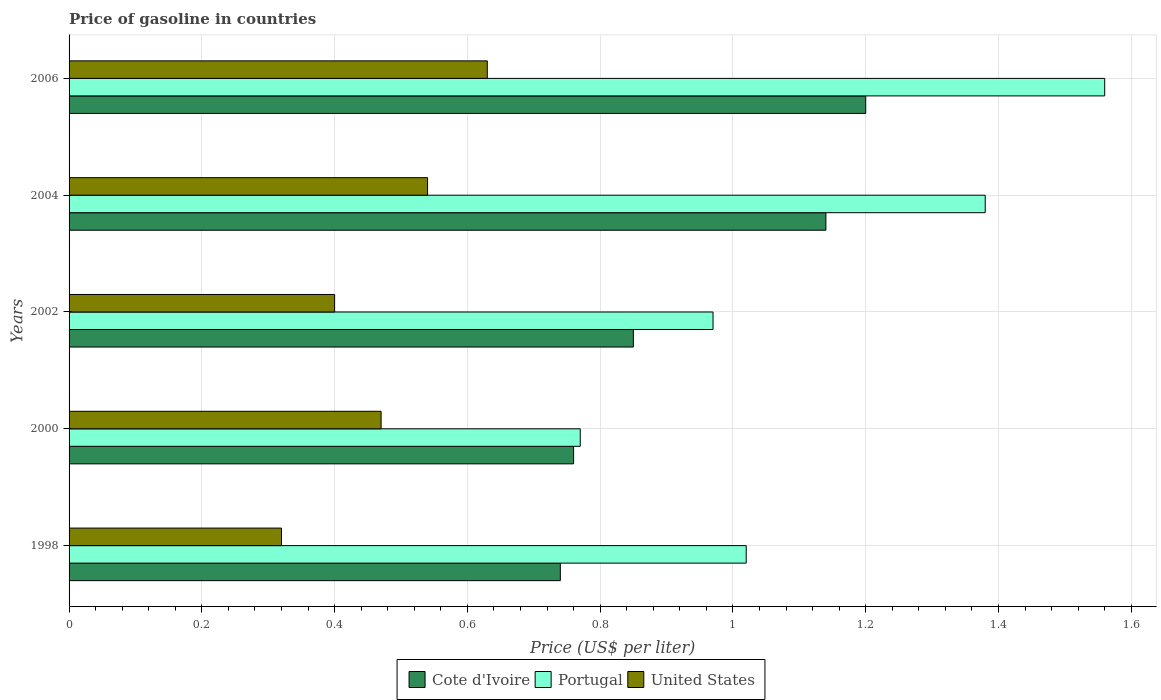How many different coloured bars are there?
Give a very brief answer. 3. How many groups of bars are there?
Provide a short and direct response. 5. Are the number of bars per tick equal to the number of legend labels?
Make the answer very short. Yes. How many bars are there on the 5th tick from the top?
Give a very brief answer. 3. How many bars are there on the 5th tick from the bottom?
Ensure brevity in your answer.  3. What is the price of gasoline in Portugal in 2000?
Keep it short and to the point. 0.77. Across all years, what is the maximum price of gasoline in Cote d'Ivoire?
Your answer should be very brief. 1.2. Across all years, what is the minimum price of gasoline in Portugal?
Give a very brief answer. 0.77. In which year was the price of gasoline in Cote d'Ivoire minimum?
Provide a short and direct response. 1998. What is the total price of gasoline in Portugal in the graph?
Provide a short and direct response. 5.7. What is the difference between the price of gasoline in United States in 2000 and that in 2006?
Your response must be concise. -0.16. What is the difference between the price of gasoline in Portugal in 2004 and the price of gasoline in United States in 2000?
Give a very brief answer. 0.91. What is the average price of gasoline in United States per year?
Offer a very short reply. 0.47. In the year 2000, what is the difference between the price of gasoline in United States and price of gasoline in Portugal?
Make the answer very short. -0.3. In how many years, is the price of gasoline in Portugal greater than 1.4800000000000002 US$?
Offer a terse response. 1. What is the ratio of the price of gasoline in Portugal in 1998 to that in 2002?
Provide a succinct answer. 1.05. What is the difference between the highest and the second highest price of gasoline in Portugal?
Your answer should be very brief. 0.18. What is the difference between the highest and the lowest price of gasoline in Cote d'Ivoire?
Offer a terse response. 0.46. In how many years, is the price of gasoline in Cote d'Ivoire greater than the average price of gasoline in Cote d'Ivoire taken over all years?
Offer a very short reply. 2. What does the 3rd bar from the top in 2000 represents?
Keep it short and to the point. Cote d'Ivoire. What does the 1st bar from the bottom in 2004 represents?
Keep it short and to the point. Cote d'Ivoire. Is it the case that in every year, the sum of the price of gasoline in United States and price of gasoline in Portugal is greater than the price of gasoline in Cote d'Ivoire?
Offer a terse response. Yes. What is the difference between two consecutive major ticks on the X-axis?
Offer a very short reply. 0.2. Are the values on the major ticks of X-axis written in scientific E-notation?
Your answer should be compact. No. Where does the legend appear in the graph?
Provide a short and direct response. Bottom center. What is the title of the graph?
Offer a terse response. Price of gasoline in countries. Does "Middle income" appear as one of the legend labels in the graph?
Your answer should be compact. No. What is the label or title of the X-axis?
Provide a succinct answer. Price (US$ per liter). What is the label or title of the Y-axis?
Provide a short and direct response. Years. What is the Price (US$ per liter) in Cote d'Ivoire in 1998?
Provide a short and direct response. 0.74. What is the Price (US$ per liter) in United States in 1998?
Ensure brevity in your answer.  0.32. What is the Price (US$ per liter) of Cote d'Ivoire in 2000?
Your response must be concise. 0.76. What is the Price (US$ per liter) of Portugal in 2000?
Ensure brevity in your answer.  0.77. What is the Price (US$ per liter) of United States in 2000?
Make the answer very short. 0.47. What is the Price (US$ per liter) in Cote d'Ivoire in 2004?
Make the answer very short. 1.14. What is the Price (US$ per liter) of Portugal in 2004?
Your answer should be very brief. 1.38. What is the Price (US$ per liter) of United States in 2004?
Make the answer very short. 0.54. What is the Price (US$ per liter) in Cote d'Ivoire in 2006?
Keep it short and to the point. 1.2. What is the Price (US$ per liter) in Portugal in 2006?
Your answer should be very brief. 1.56. What is the Price (US$ per liter) of United States in 2006?
Your answer should be very brief. 0.63. Across all years, what is the maximum Price (US$ per liter) of Cote d'Ivoire?
Give a very brief answer. 1.2. Across all years, what is the maximum Price (US$ per liter) of Portugal?
Offer a very short reply. 1.56. Across all years, what is the maximum Price (US$ per liter) in United States?
Make the answer very short. 0.63. Across all years, what is the minimum Price (US$ per liter) in Cote d'Ivoire?
Make the answer very short. 0.74. Across all years, what is the minimum Price (US$ per liter) in Portugal?
Provide a succinct answer. 0.77. Across all years, what is the minimum Price (US$ per liter) of United States?
Your answer should be very brief. 0.32. What is the total Price (US$ per liter) of Cote d'Ivoire in the graph?
Your response must be concise. 4.69. What is the total Price (US$ per liter) in United States in the graph?
Your response must be concise. 2.36. What is the difference between the Price (US$ per liter) of Cote d'Ivoire in 1998 and that in 2000?
Your answer should be compact. -0.02. What is the difference between the Price (US$ per liter) of Portugal in 1998 and that in 2000?
Provide a succinct answer. 0.25. What is the difference between the Price (US$ per liter) of Cote d'Ivoire in 1998 and that in 2002?
Offer a terse response. -0.11. What is the difference between the Price (US$ per liter) in Portugal in 1998 and that in 2002?
Make the answer very short. 0.05. What is the difference between the Price (US$ per liter) of United States in 1998 and that in 2002?
Give a very brief answer. -0.08. What is the difference between the Price (US$ per liter) in Cote d'Ivoire in 1998 and that in 2004?
Your answer should be very brief. -0.4. What is the difference between the Price (US$ per liter) of Portugal in 1998 and that in 2004?
Make the answer very short. -0.36. What is the difference between the Price (US$ per liter) in United States in 1998 and that in 2004?
Keep it short and to the point. -0.22. What is the difference between the Price (US$ per liter) of Cote d'Ivoire in 1998 and that in 2006?
Offer a terse response. -0.46. What is the difference between the Price (US$ per liter) of Portugal in 1998 and that in 2006?
Your answer should be compact. -0.54. What is the difference between the Price (US$ per liter) of United States in 1998 and that in 2006?
Make the answer very short. -0.31. What is the difference between the Price (US$ per liter) in Cote d'Ivoire in 2000 and that in 2002?
Offer a terse response. -0.09. What is the difference between the Price (US$ per liter) in United States in 2000 and that in 2002?
Give a very brief answer. 0.07. What is the difference between the Price (US$ per liter) of Cote d'Ivoire in 2000 and that in 2004?
Provide a succinct answer. -0.38. What is the difference between the Price (US$ per liter) of Portugal in 2000 and that in 2004?
Make the answer very short. -0.61. What is the difference between the Price (US$ per liter) of United States in 2000 and that in 2004?
Keep it short and to the point. -0.07. What is the difference between the Price (US$ per liter) in Cote d'Ivoire in 2000 and that in 2006?
Your response must be concise. -0.44. What is the difference between the Price (US$ per liter) of Portugal in 2000 and that in 2006?
Make the answer very short. -0.79. What is the difference between the Price (US$ per liter) in United States in 2000 and that in 2006?
Offer a terse response. -0.16. What is the difference between the Price (US$ per liter) in Cote d'Ivoire in 2002 and that in 2004?
Ensure brevity in your answer.  -0.29. What is the difference between the Price (US$ per liter) of Portugal in 2002 and that in 2004?
Ensure brevity in your answer.  -0.41. What is the difference between the Price (US$ per liter) of United States in 2002 and that in 2004?
Offer a terse response. -0.14. What is the difference between the Price (US$ per liter) of Cote d'Ivoire in 2002 and that in 2006?
Provide a succinct answer. -0.35. What is the difference between the Price (US$ per liter) in Portugal in 2002 and that in 2006?
Ensure brevity in your answer.  -0.59. What is the difference between the Price (US$ per liter) of United States in 2002 and that in 2006?
Provide a short and direct response. -0.23. What is the difference between the Price (US$ per liter) of Cote d'Ivoire in 2004 and that in 2006?
Offer a terse response. -0.06. What is the difference between the Price (US$ per liter) in Portugal in 2004 and that in 2006?
Your answer should be very brief. -0.18. What is the difference between the Price (US$ per liter) in United States in 2004 and that in 2006?
Ensure brevity in your answer.  -0.09. What is the difference between the Price (US$ per liter) in Cote d'Ivoire in 1998 and the Price (US$ per liter) in Portugal in 2000?
Offer a terse response. -0.03. What is the difference between the Price (US$ per liter) in Cote d'Ivoire in 1998 and the Price (US$ per liter) in United States in 2000?
Make the answer very short. 0.27. What is the difference between the Price (US$ per liter) of Portugal in 1998 and the Price (US$ per liter) of United States in 2000?
Give a very brief answer. 0.55. What is the difference between the Price (US$ per liter) of Cote d'Ivoire in 1998 and the Price (US$ per liter) of Portugal in 2002?
Your response must be concise. -0.23. What is the difference between the Price (US$ per liter) in Cote d'Ivoire in 1998 and the Price (US$ per liter) in United States in 2002?
Give a very brief answer. 0.34. What is the difference between the Price (US$ per liter) in Portugal in 1998 and the Price (US$ per liter) in United States in 2002?
Ensure brevity in your answer.  0.62. What is the difference between the Price (US$ per liter) in Cote d'Ivoire in 1998 and the Price (US$ per liter) in Portugal in 2004?
Your answer should be very brief. -0.64. What is the difference between the Price (US$ per liter) in Cote d'Ivoire in 1998 and the Price (US$ per liter) in United States in 2004?
Ensure brevity in your answer.  0.2. What is the difference between the Price (US$ per liter) in Portugal in 1998 and the Price (US$ per liter) in United States in 2004?
Offer a very short reply. 0.48. What is the difference between the Price (US$ per liter) of Cote d'Ivoire in 1998 and the Price (US$ per liter) of Portugal in 2006?
Your answer should be compact. -0.82. What is the difference between the Price (US$ per liter) of Cote d'Ivoire in 1998 and the Price (US$ per liter) of United States in 2006?
Offer a very short reply. 0.11. What is the difference between the Price (US$ per liter) in Portugal in 1998 and the Price (US$ per liter) in United States in 2006?
Provide a short and direct response. 0.39. What is the difference between the Price (US$ per liter) of Cote d'Ivoire in 2000 and the Price (US$ per liter) of Portugal in 2002?
Your answer should be compact. -0.21. What is the difference between the Price (US$ per liter) of Cote d'Ivoire in 2000 and the Price (US$ per liter) of United States in 2002?
Provide a succinct answer. 0.36. What is the difference between the Price (US$ per liter) in Portugal in 2000 and the Price (US$ per liter) in United States in 2002?
Offer a very short reply. 0.37. What is the difference between the Price (US$ per liter) in Cote d'Ivoire in 2000 and the Price (US$ per liter) in Portugal in 2004?
Provide a short and direct response. -0.62. What is the difference between the Price (US$ per liter) of Cote d'Ivoire in 2000 and the Price (US$ per liter) of United States in 2004?
Your answer should be compact. 0.22. What is the difference between the Price (US$ per liter) of Portugal in 2000 and the Price (US$ per liter) of United States in 2004?
Provide a short and direct response. 0.23. What is the difference between the Price (US$ per liter) in Cote d'Ivoire in 2000 and the Price (US$ per liter) in United States in 2006?
Offer a terse response. 0.13. What is the difference between the Price (US$ per liter) of Portugal in 2000 and the Price (US$ per liter) of United States in 2006?
Ensure brevity in your answer.  0.14. What is the difference between the Price (US$ per liter) of Cote d'Ivoire in 2002 and the Price (US$ per liter) of Portugal in 2004?
Give a very brief answer. -0.53. What is the difference between the Price (US$ per liter) of Cote d'Ivoire in 2002 and the Price (US$ per liter) of United States in 2004?
Provide a short and direct response. 0.31. What is the difference between the Price (US$ per liter) of Portugal in 2002 and the Price (US$ per liter) of United States in 2004?
Give a very brief answer. 0.43. What is the difference between the Price (US$ per liter) in Cote d'Ivoire in 2002 and the Price (US$ per liter) in Portugal in 2006?
Provide a succinct answer. -0.71. What is the difference between the Price (US$ per liter) in Cote d'Ivoire in 2002 and the Price (US$ per liter) in United States in 2006?
Keep it short and to the point. 0.22. What is the difference between the Price (US$ per liter) in Portugal in 2002 and the Price (US$ per liter) in United States in 2006?
Ensure brevity in your answer.  0.34. What is the difference between the Price (US$ per liter) of Cote d'Ivoire in 2004 and the Price (US$ per liter) of Portugal in 2006?
Provide a succinct answer. -0.42. What is the difference between the Price (US$ per liter) of Cote d'Ivoire in 2004 and the Price (US$ per liter) of United States in 2006?
Your answer should be very brief. 0.51. What is the difference between the Price (US$ per liter) in Portugal in 2004 and the Price (US$ per liter) in United States in 2006?
Make the answer very short. 0.75. What is the average Price (US$ per liter) of Cote d'Ivoire per year?
Give a very brief answer. 0.94. What is the average Price (US$ per liter) in Portugal per year?
Provide a short and direct response. 1.14. What is the average Price (US$ per liter) of United States per year?
Your answer should be compact. 0.47. In the year 1998, what is the difference between the Price (US$ per liter) in Cote d'Ivoire and Price (US$ per liter) in Portugal?
Offer a very short reply. -0.28. In the year 1998, what is the difference between the Price (US$ per liter) in Cote d'Ivoire and Price (US$ per liter) in United States?
Your answer should be very brief. 0.42. In the year 2000, what is the difference between the Price (US$ per liter) of Cote d'Ivoire and Price (US$ per liter) of Portugal?
Your response must be concise. -0.01. In the year 2000, what is the difference between the Price (US$ per liter) in Cote d'Ivoire and Price (US$ per liter) in United States?
Your response must be concise. 0.29. In the year 2002, what is the difference between the Price (US$ per liter) in Cote d'Ivoire and Price (US$ per liter) in Portugal?
Provide a short and direct response. -0.12. In the year 2002, what is the difference between the Price (US$ per liter) of Cote d'Ivoire and Price (US$ per liter) of United States?
Provide a short and direct response. 0.45. In the year 2002, what is the difference between the Price (US$ per liter) of Portugal and Price (US$ per liter) of United States?
Make the answer very short. 0.57. In the year 2004, what is the difference between the Price (US$ per liter) of Cote d'Ivoire and Price (US$ per liter) of Portugal?
Your answer should be very brief. -0.24. In the year 2004, what is the difference between the Price (US$ per liter) of Portugal and Price (US$ per liter) of United States?
Provide a short and direct response. 0.84. In the year 2006, what is the difference between the Price (US$ per liter) in Cote d'Ivoire and Price (US$ per liter) in Portugal?
Your response must be concise. -0.36. In the year 2006, what is the difference between the Price (US$ per liter) in Cote d'Ivoire and Price (US$ per liter) in United States?
Provide a succinct answer. 0.57. What is the ratio of the Price (US$ per liter) of Cote d'Ivoire in 1998 to that in 2000?
Your answer should be compact. 0.97. What is the ratio of the Price (US$ per liter) in Portugal in 1998 to that in 2000?
Your answer should be very brief. 1.32. What is the ratio of the Price (US$ per liter) of United States in 1998 to that in 2000?
Your answer should be very brief. 0.68. What is the ratio of the Price (US$ per liter) of Cote d'Ivoire in 1998 to that in 2002?
Your response must be concise. 0.87. What is the ratio of the Price (US$ per liter) of Portugal in 1998 to that in 2002?
Your answer should be compact. 1.05. What is the ratio of the Price (US$ per liter) of United States in 1998 to that in 2002?
Ensure brevity in your answer.  0.8. What is the ratio of the Price (US$ per liter) in Cote d'Ivoire in 1998 to that in 2004?
Ensure brevity in your answer.  0.65. What is the ratio of the Price (US$ per liter) in Portugal in 1998 to that in 2004?
Ensure brevity in your answer.  0.74. What is the ratio of the Price (US$ per liter) in United States in 1998 to that in 2004?
Give a very brief answer. 0.59. What is the ratio of the Price (US$ per liter) of Cote d'Ivoire in 1998 to that in 2006?
Your answer should be compact. 0.62. What is the ratio of the Price (US$ per liter) of Portugal in 1998 to that in 2006?
Give a very brief answer. 0.65. What is the ratio of the Price (US$ per liter) in United States in 1998 to that in 2006?
Provide a succinct answer. 0.51. What is the ratio of the Price (US$ per liter) in Cote d'Ivoire in 2000 to that in 2002?
Your answer should be very brief. 0.89. What is the ratio of the Price (US$ per liter) in Portugal in 2000 to that in 2002?
Keep it short and to the point. 0.79. What is the ratio of the Price (US$ per liter) in United States in 2000 to that in 2002?
Give a very brief answer. 1.18. What is the ratio of the Price (US$ per liter) of Portugal in 2000 to that in 2004?
Your response must be concise. 0.56. What is the ratio of the Price (US$ per liter) in United States in 2000 to that in 2004?
Your answer should be compact. 0.87. What is the ratio of the Price (US$ per liter) of Cote d'Ivoire in 2000 to that in 2006?
Make the answer very short. 0.63. What is the ratio of the Price (US$ per liter) of Portugal in 2000 to that in 2006?
Your response must be concise. 0.49. What is the ratio of the Price (US$ per liter) of United States in 2000 to that in 2006?
Provide a succinct answer. 0.75. What is the ratio of the Price (US$ per liter) of Cote d'Ivoire in 2002 to that in 2004?
Provide a succinct answer. 0.75. What is the ratio of the Price (US$ per liter) of Portugal in 2002 to that in 2004?
Offer a very short reply. 0.7. What is the ratio of the Price (US$ per liter) of United States in 2002 to that in 2004?
Offer a very short reply. 0.74. What is the ratio of the Price (US$ per liter) of Cote d'Ivoire in 2002 to that in 2006?
Your answer should be compact. 0.71. What is the ratio of the Price (US$ per liter) in Portugal in 2002 to that in 2006?
Provide a succinct answer. 0.62. What is the ratio of the Price (US$ per liter) in United States in 2002 to that in 2006?
Ensure brevity in your answer.  0.63. What is the ratio of the Price (US$ per liter) in Portugal in 2004 to that in 2006?
Your answer should be compact. 0.88. What is the ratio of the Price (US$ per liter) in United States in 2004 to that in 2006?
Make the answer very short. 0.86. What is the difference between the highest and the second highest Price (US$ per liter) of Cote d'Ivoire?
Your answer should be compact. 0.06. What is the difference between the highest and the second highest Price (US$ per liter) in Portugal?
Your response must be concise. 0.18. What is the difference between the highest and the second highest Price (US$ per liter) of United States?
Provide a short and direct response. 0.09. What is the difference between the highest and the lowest Price (US$ per liter) of Cote d'Ivoire?
Offer a very short reply. 0.46. What is the difference between the highest and the lowest Price (US$ per liter) of Portugal?
Your answer should be compact. 0.79. What is the difference between the highest and the lowest Price (US$ per liter) in United States?
Your answer should be very brief. 0.31. 